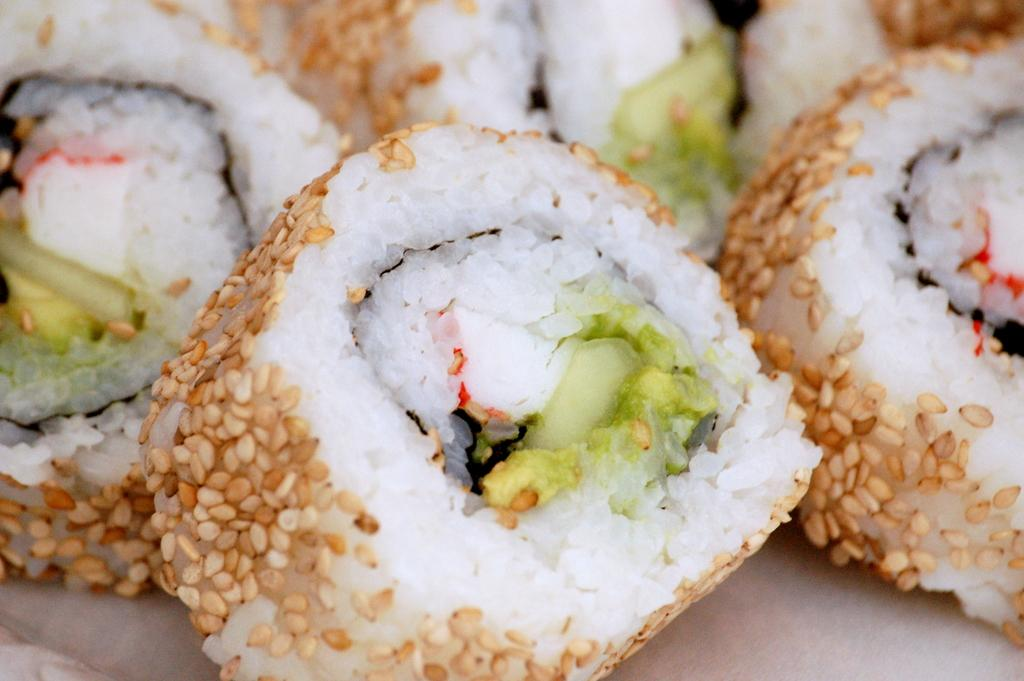What is the main subject of the picture? The main subject of the picture is food. Can you describe the appearance of the food? The food has cream and white colors. How many friends are visible in the picture? There are no friends present in the image; it only features food. 